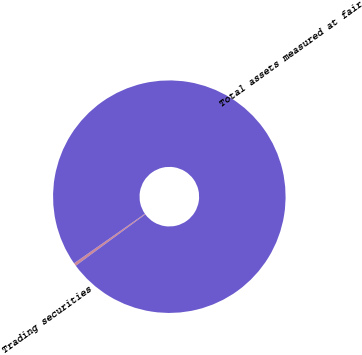Convert chart. <chart><loc_0><loc_0><loc_500><loc_500><pie_chart><fcel>Trading securities<fcel>Total assets measured at fair<nl><fcel>0.41%<fcel>99.59%<nl></chart> 